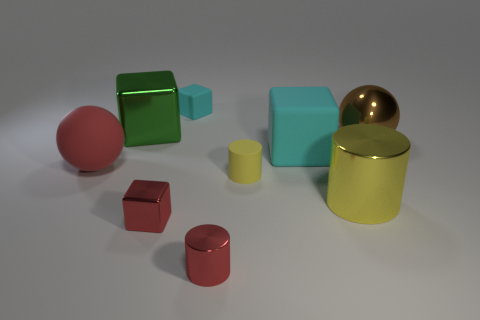How many objects are both behind the red cylinder and in front of the tiny yellow cylinder?
Offer a very short reply. 2. What number of cylinders are either large purple metallic things or yellow things?
Provide a succinct answer. 2. Is there a big green cube?
Your response must be concise. Yes. How many other things are there of the same material as the big cyan block?
Keep it short and to the point. 3. There is a cylinder that is the same size as the brown metal thing; what material is it?
Give a very brief answer. Metal. Do the large object that is behind the large brown ball and the red matte thing have the same shape?
Keep it short and to the point. No. Do the small shiny cube and the big metal cylinder have the same color?
Your response must be concise. No. What number of objects are either small blocks that are behind the red matte ball or tiny yellow objects?
Offer a terse response. 2. There is a cyan matte thing that is the same size as the brown metallic sphere; what is its shape?
Make the answer very short. Cube. There is a yellow thing that is left of the large cyan rubber cube; is its size the same as the metal block in front of the green metallic thing?
Ensure brevity in your answer.  Yes. 